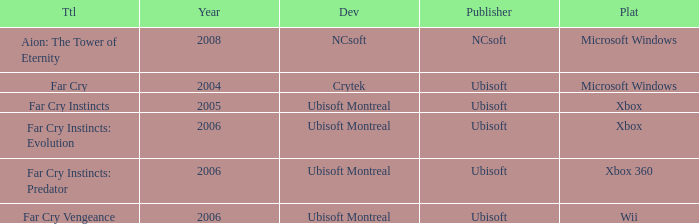Which xbox platform title has a release date preceding 2006? Far Cry Instincts. 